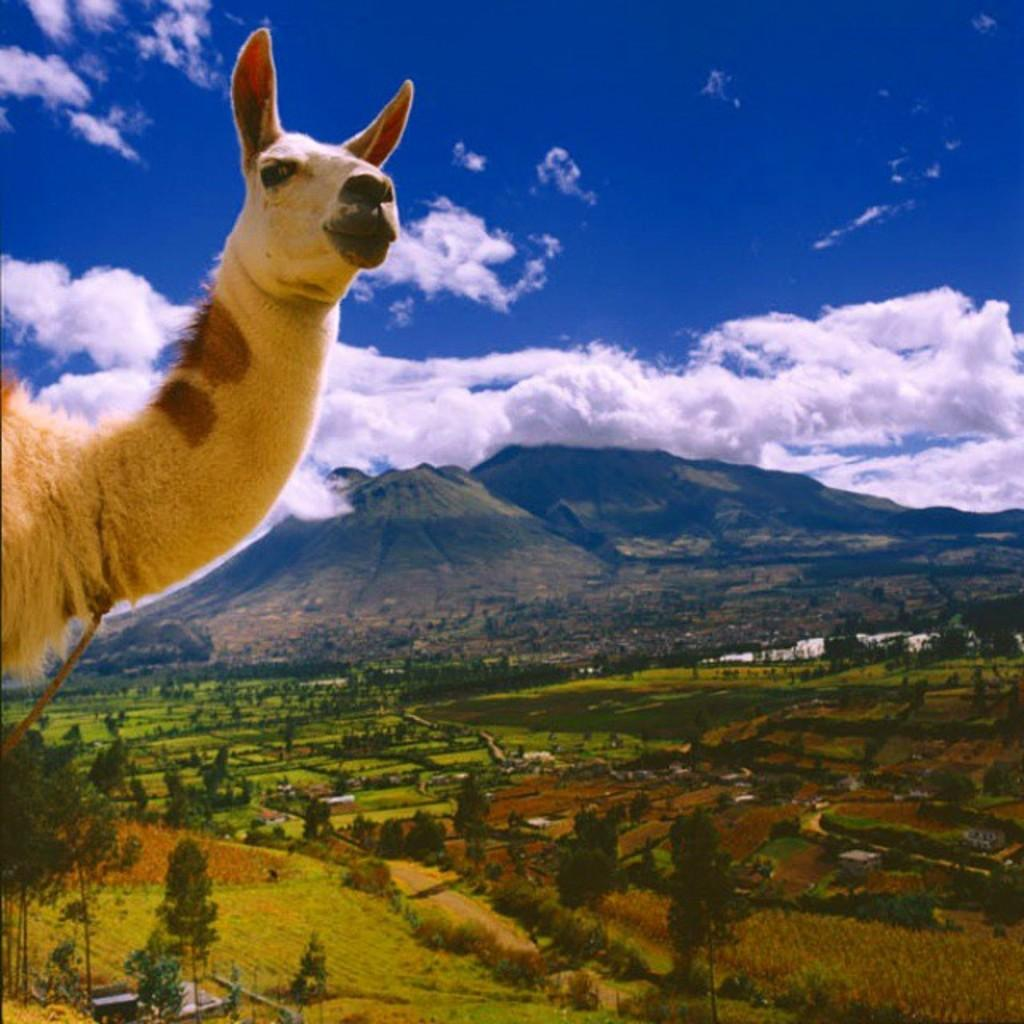What type of animal can be seen in the image? There is an animal in the image, but its specific type cannot be determined from the facts provided. What type of vegetation is present at the bottom of the image? There are trees on the grassland at the bottom of the image. What geographical features can be seen in the background of the image? There are hills in the background of the image. What is visible at the top of the image? The sky is visible at the top of the image. What can be seen in the sky? There are clouds in the sky. How many eggs does the animal have in the image? There is no mention of eggs in the image, so it is impossible to determine how many the animal might have. 